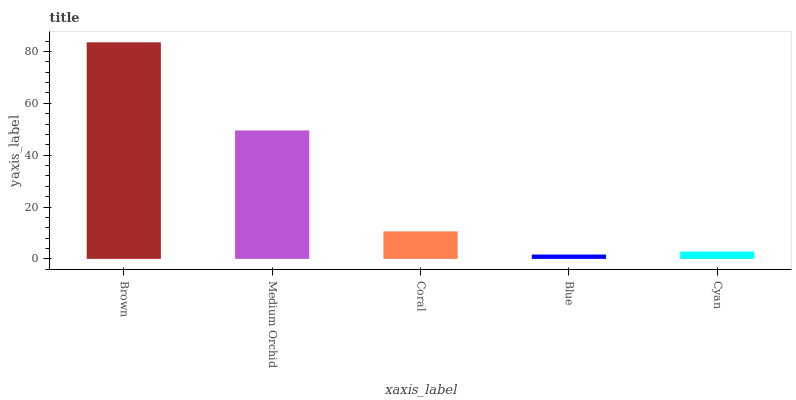Is Blue the minimum?
Answer yes or no. Yes. Is Brown the maximum?
Answer yes or no. Yes. Is Medium Orchid the minimum?
Answer yes or no. No. Is Medium Orchid the maximum?
Answer yes or no. No. Is Brown greater than Medium Orchid?
Answer yes or no. Yes. Is Medium Orchid less than Brown?
Answer yes or no. Yes. Is Medium Orchid greater than Brown?
Answer yes or no. No. Is Brown less than Medium Orchid?
Answer yes or no. No. Is Coral the high median?
Answer yes or no. Yes. Is Coral the low median?
Answer yes or no. Yes. Is Brown the high median?
Answer yes or no. No. Is Medium Orchid the low median?
Answer yes or no. No. 